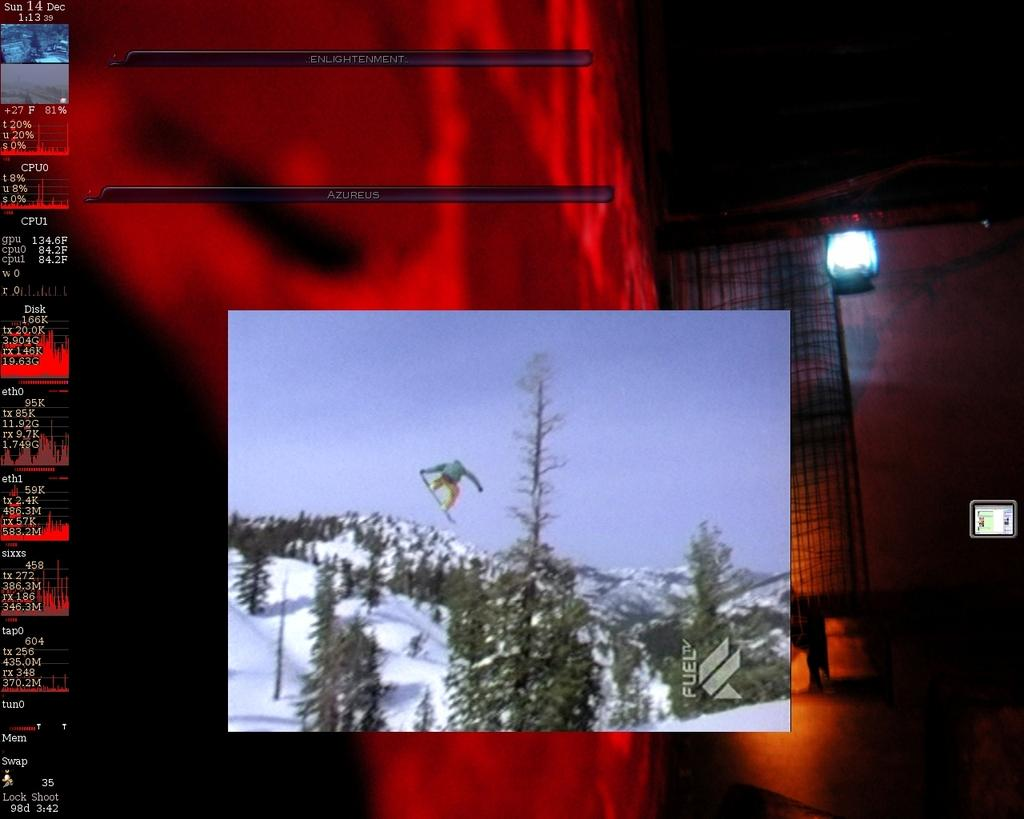What can be observed about the image's appearance? The image is edited. What is located in the center of the image? There are trees in the center of the image. What type of weather is depicted in the image? There is snow in the image. What type of landscape is visible in the image? There are mountains in the image. What type of tub is visible in the image? There is no tub present in the image. What idea does the society in the image represent? There is no society depicted in the image, so it is not possible to determine what idea it might represent. 